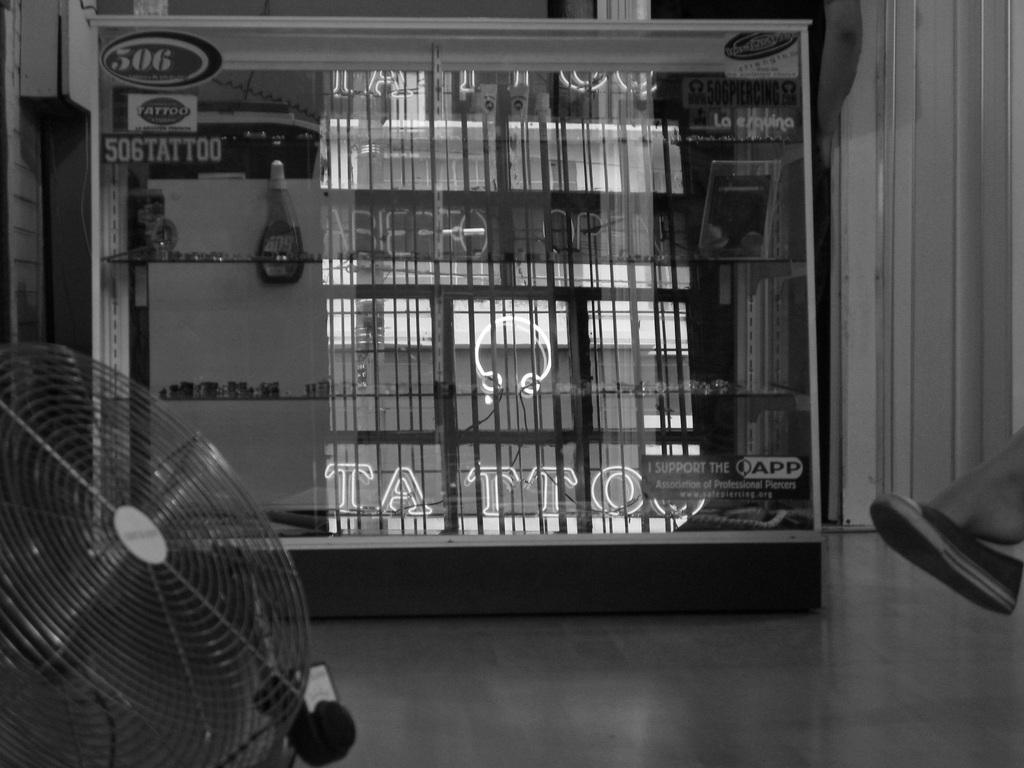Who is the person mentioned in the image? There is a person named Dan in the image. What can be seen on the shelf in the image? There is a shelf with objects in the image. What is the temper of the coach in the image? There is no coach present in the image, so it is not possible to determine the temper of a coach. 